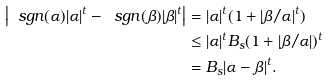Convert formula to latex. <formula><loc_0><loc_0><loc_500><loc_500>\left | \ s g n ( \alpha ) | \alpha | ^ { t } - \ s g n ( \beta ) | \beta | ^ { t } \right | & = | \alpha | ^ { t } ( 1 + | \beta / \alpha | ^ { t } ) \\ & \leq | \alpha | ^ { t } B _ { s } ( 1 + | \beta / \alpha | ) ^ { t } \\ & = B _ { s } | \alpha - \beta | ^ { t } .</formula> 